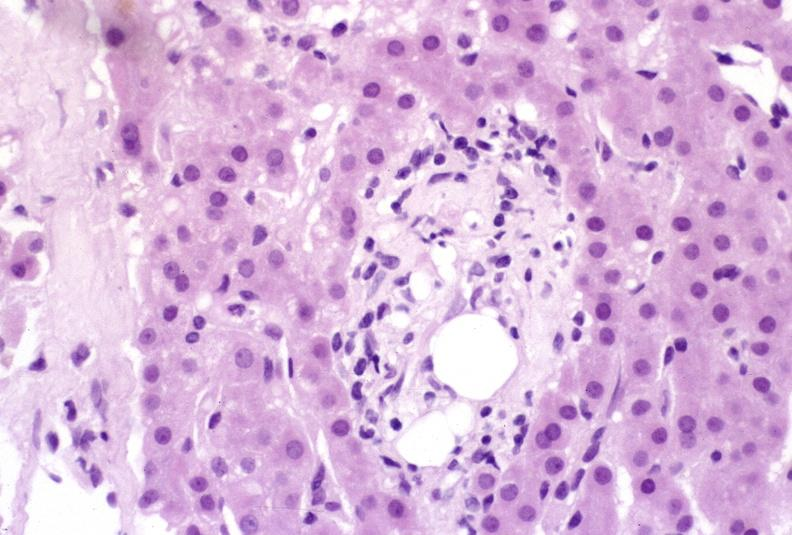does this image show ductopenia?
Answer the question using a single word or phrase. Yes 